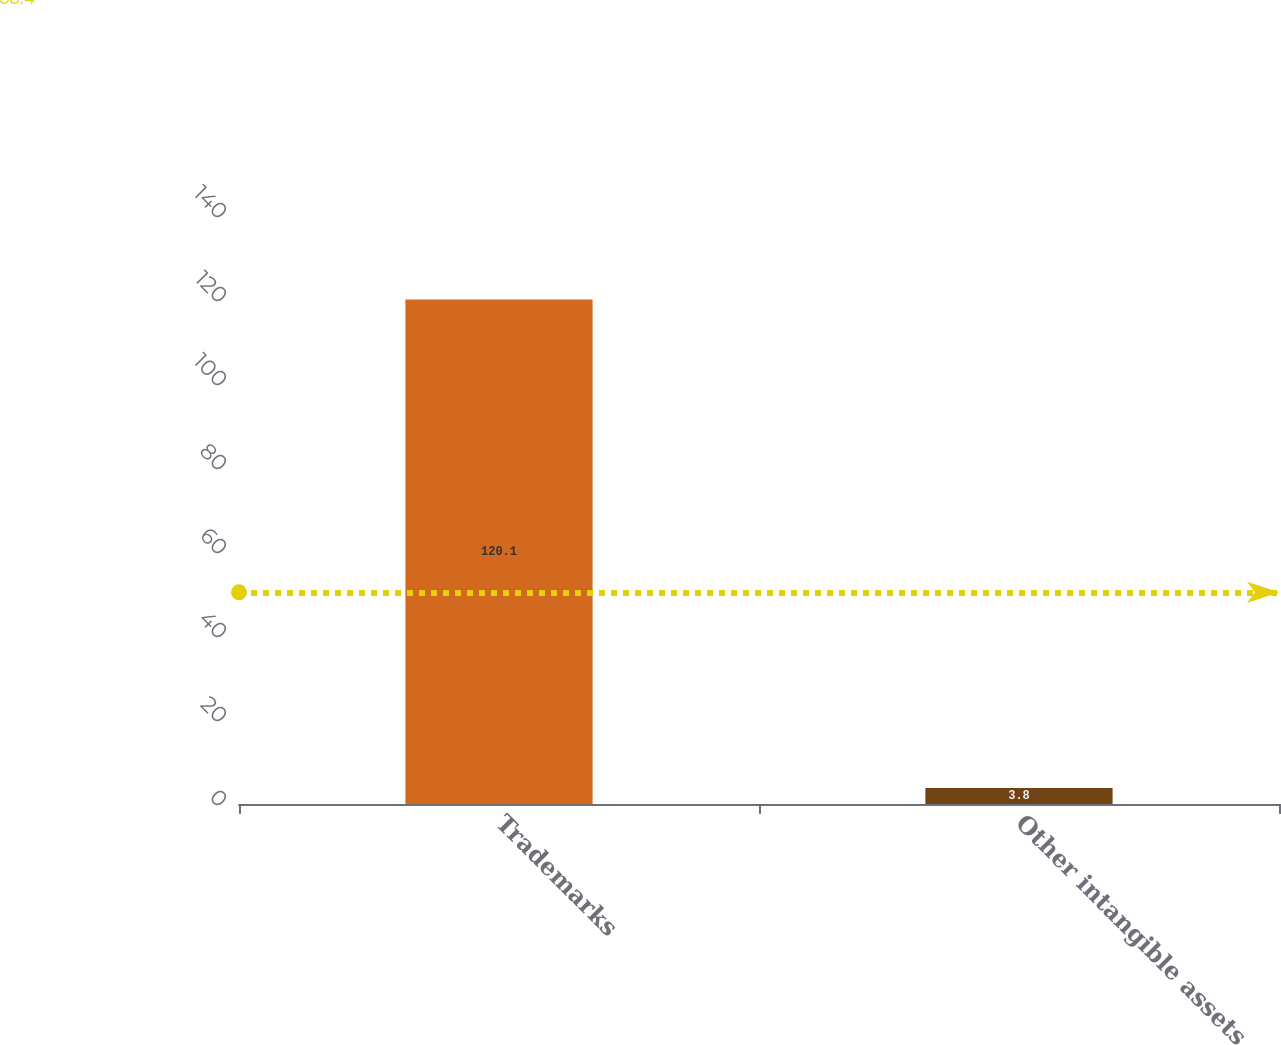<chart> <loc_0><loc_0><loc_500><loc_500><bar_chart><fcel>Trademarks<fcel>Other intangible assets<nl><fcel>120.1<fcel>3.8<nl></chart> 